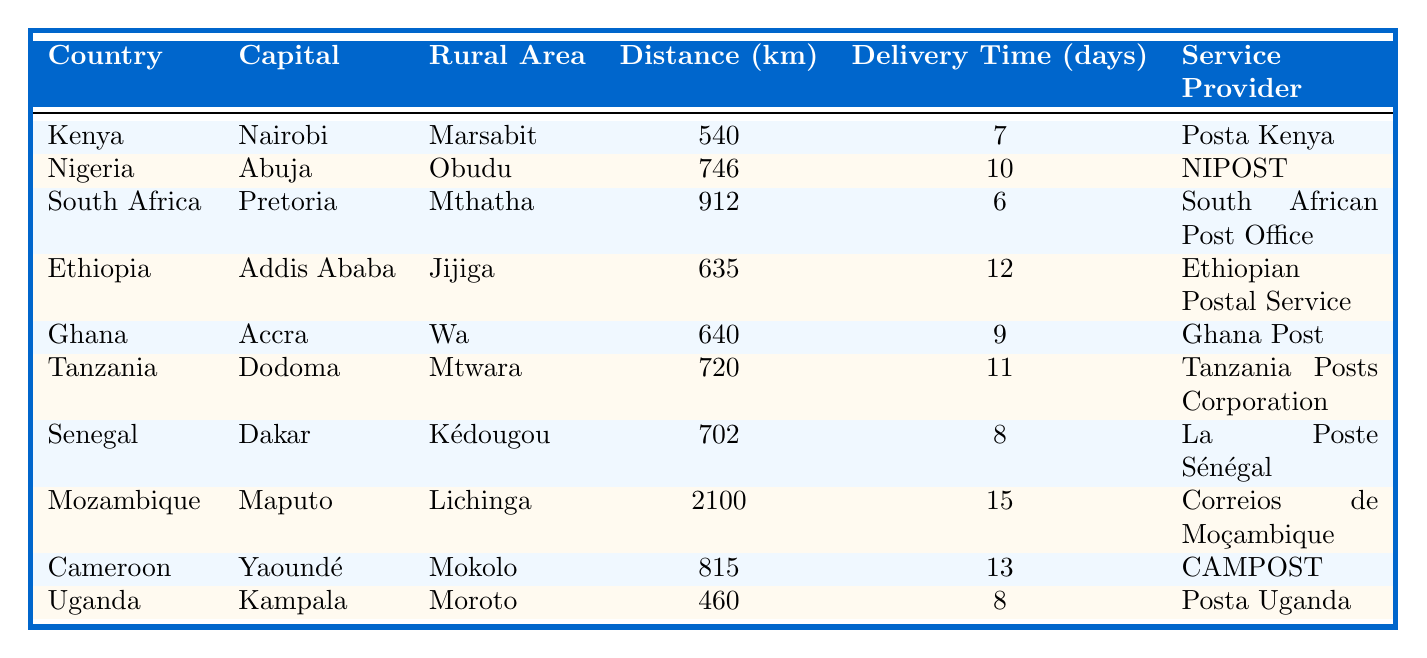What is the delivery time for parcels from Kenya to Marsabit? The table indicates that the delivery time for parcels from Nairobi, the capital of Kenya, to Marsabit is 7 days.
Answer: 7 days Which country has the shortest delivery time for parcels to its rural area? Looking through the delivery times listed, South Africa has the shortest delivery time of 6 days for parcels sent to Mthatha.
Answer: South Africa What is the total distance covered when sending parcels from Nigeria to Obudu and from Tanzania to Mtwara? The distance from Abuja to Obudu is 746 km, and from Dodoma to Mtwara is 720 km. Adding these gives 746 + 720 = 1466 km.
Answer: 1466 km Is the delivery time from Mozambique to Lichinga longer than 10 days? The delivery time from Maputo to Lichinga is 15 days, which is more than 10 days.
Answer: Yes Which country has a rural area that is furthest from its capital, and what is the distance? Mozambique's rural area Lichinga is furthest from Maputo at a distance of 2100 km.
Answer: Mozambique, 2100 km What is the average delivery time for parcels from the capitals listed? The delivery times are 7, 10, 6, 12, 9, 11, 8, 15, 13, and 8 days, totaling 89 days. There are 10 countries, so the average is 89 / 10 = 8.9 days.
Answer: 8.9 days Are there more countries with a delivery time of more than 10 days or less than 10 days? There are 4 countries with a delivery time of more than 10 days (Ethiopia, Tanzania, Mozambique, Cameroon) and 6 countries with less than 10 days. Therefore, there are more countries with less than 10 days.
Answer: Less than 10 days What is the delivery time difference between parcels sent from Uganda to Moroto and from Kenya to Marsabit? The delivery time to Moroto is 8 days and to Marsabit is 7 days. The difference is 8 - 7 = 1 day.
Answer: 1 day Which service provider has the longest delivery time? Comparing the delivery times, Correios de Moçambique delivers parcels to Lichinga in 15 days, which is the longest delivery time.
Answer: Correios de Moçambique How many countries have a delivery time of exactly 8 days? The table shows that Uganda and Senegal both have a delivery time of 8 days, totaling 2 countries.
Answer: 2 countries Which rural area has a shorter distance from its capital: Mthatha in South Africa or Wa in Ghana? The distance to Mthatha is 912 km, while Wa is 640 km. Since 640 km is shorter than 912 km, Wa has a shorter distance.
Answer: Wa 